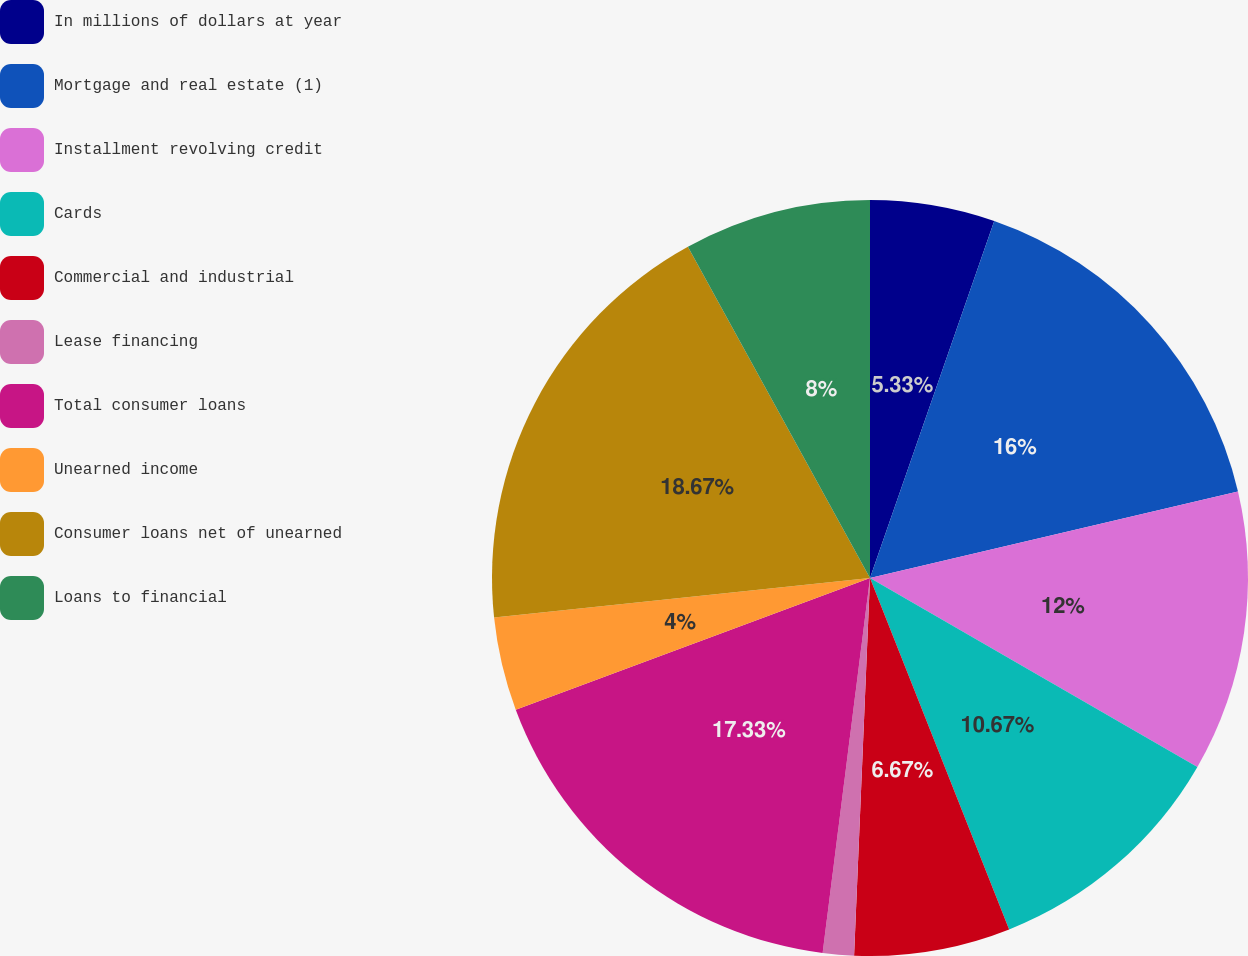Convert chart. <chart><loc_0><loc_0><loc_500><loc_500><pie_chart><fcel>In millions of dollars at year<fcel>Mortgage and real estate (1)<fcel>Installment revolving credit<fcel>Cards<fcel>Commercial and industrial<fcel>Lease financing<fcel>Total consumer loans<fcel>Unearned income<fcel>Consumer loans net of unearned<fcel>Loans to financial<nl><fcel>5.33%<fcel>16.0%<fcel>12.0%<fcel>10.67%<fcel>6.67%<fcel>1.33%<fcel>17.33%<fcel>4.0%<fcel>18.67%<fcel>8.0%<nl></chart> 